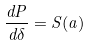Convert formula to latex. <formula><loc_0><loc_0><loc_500><loc_500>\frac { d P } { d \delta } = S ( a )</formula> 